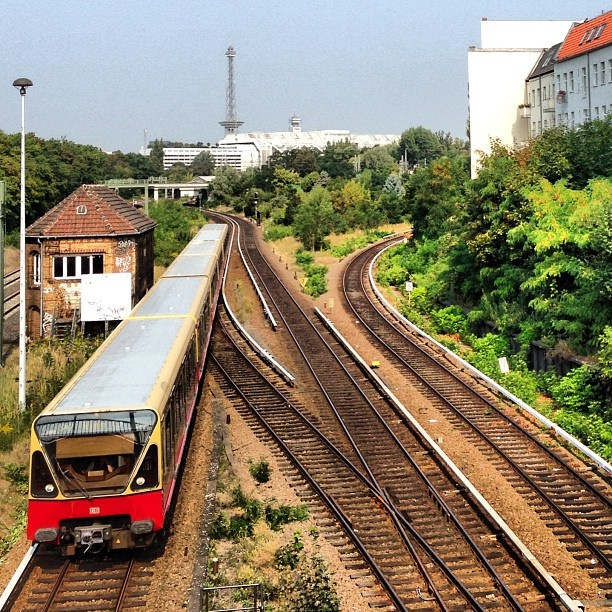Describe the objects in this image and their specific colors. I can see a train in lightblue, lightgray, black, tan, and red tones in this image. 